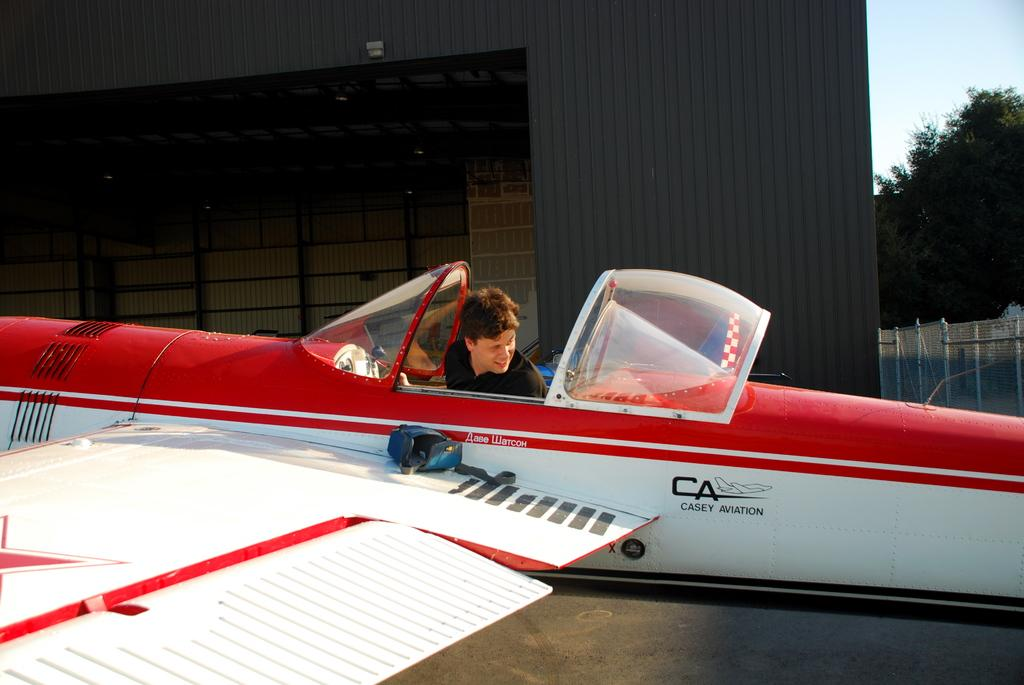<image>
Share a concise interpretation of the image provided. A man is sitting in a small white airplane that says Casey Aviation. 